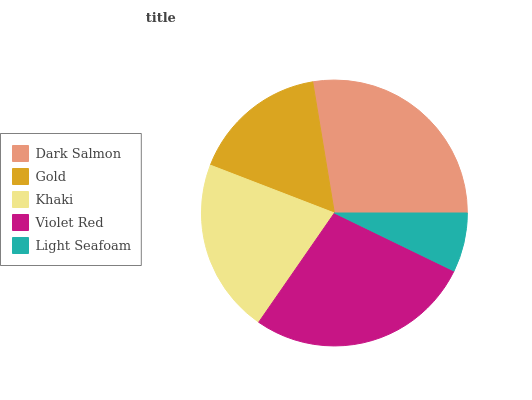Is Light Seafoam the minimum?
Answer yes or no. Yes. Is Dark Salmon the maximum?
Answer yes or no. Yes. Is Gold the minimum?
Answer yes or no. No. Is Gold the maximum?
Answer yes or no. No. Is Dark Salmon greater than Gold?
Answer yes or no. Yes. Is Gold less than Dark Salmon?
Answer yes or no. Yes. Is Gold greater than Dark Salmon?
Answer yes or no. No. Is Dark Salmon less than Gold?
Answer yes or no. No. Is Khaki the high median?
Answer yes or no. Yes. Is Khaki the low median?
Answer yes or no. Yes. Is Gold the high median?
Answer yes or no. No. Is Violet Red the low median?
Answer yes or no. No. 